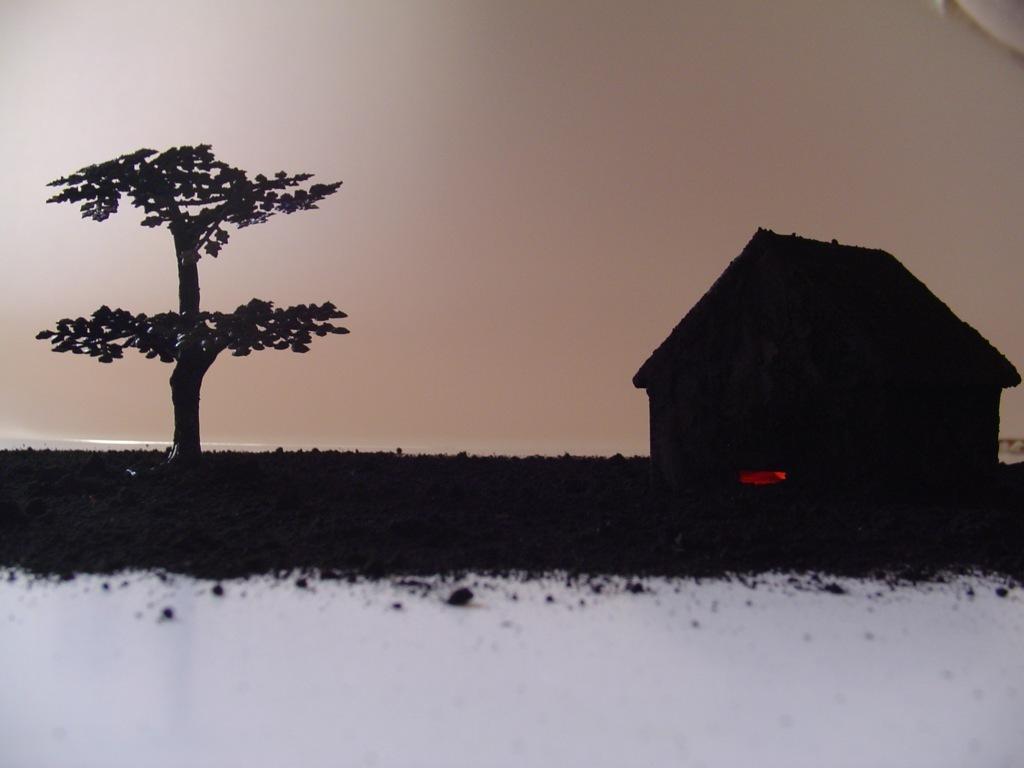Describe this image in one or two sentences. This image is taken outdoors. At the top of the image there is the sky. On the left side of the image there is a tree. On the right side of the image there is a hut. At the bottom of the image there is snow on the ground. 